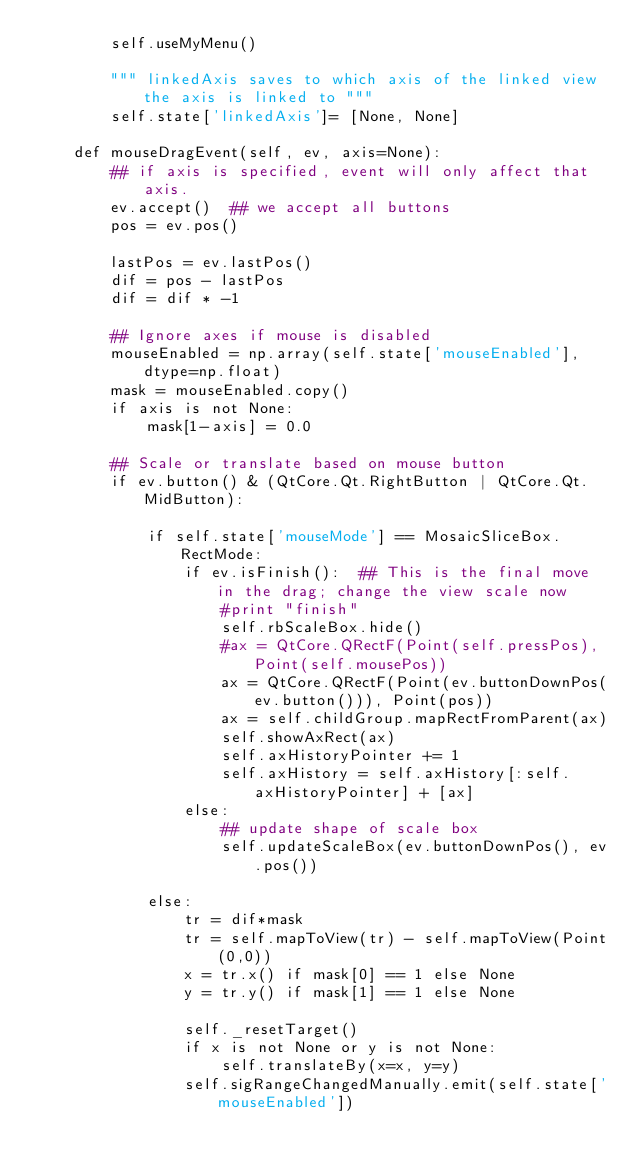<code> <loc_0><loc_0><loc_500><loc_500><_Python_>        self.useMyMenu()

        """ linkedAxis saves to which axis of the linked view the axis is linked to """
        self.state['linkedAxis']= [None, None]

    def mouseDragEvent(self, ev, axis=None):
        ## if axis is specified, event will only affect that axis.
        ev.accept()  ## we accept all buttons
        pos = ev.pos()

        lastPos = ev.lastPos()
        dif = pos - lastPos
        dif = dif * -1

        ## Ignore axes if mouse is disabled
        mouseEnabled = np.array(self.state['mouseEnabled'], dtype=np.float)
        mask = mouseEnabled.copy()
        if axis is not None:
            mask[1-axis] = 0.0

        ## Scale or translate based on mouse button
        if ev.button() & (QtCore.Qt.RightButton | QtCore.Qt.MidButton):

            if self.state['mouseMode'] == MosaicSliceBox.RectMode:
                if ev.isFinish():  ## This is the final move in the drag; change the view scale now
                    #print "finish"
                    self.rbScaleBox.hide()
                    #ax = QtCore.QRectF(Point(self.pressPos), Point(self.mousePos))
                    ax = QtCore.QRectF(Point(ev.buttonDownPos(ev.button())), Point(pos))
                    ax = self.childGroup.mapRectFromParent(ax)
                    self.showAxRect(ax)
                    self.axHistoryPointer += 1
                    self.axHistory = self.axHistory[:self.axHistoryPointer] + [ax]
                else:
                    ## update shape of scale box
                    self.updateScaleBox(ev.buttonDownPos(), ev.pos())

            else:
                tr = dif*mask
                tr = self.mapToView(tr) - self.mapToView(Point(0,0))
                x = tr.x() if mask[0] == 1 else None
                y = tr.y() if mask[1] == 1 else None

                self._resetTarget()
                if x is not None or y is not None:
                    self.translateBy(x=x, y=y)
                self.sigRangeChangedManually.emit(self.state['mouseEnabled'])
</code> 